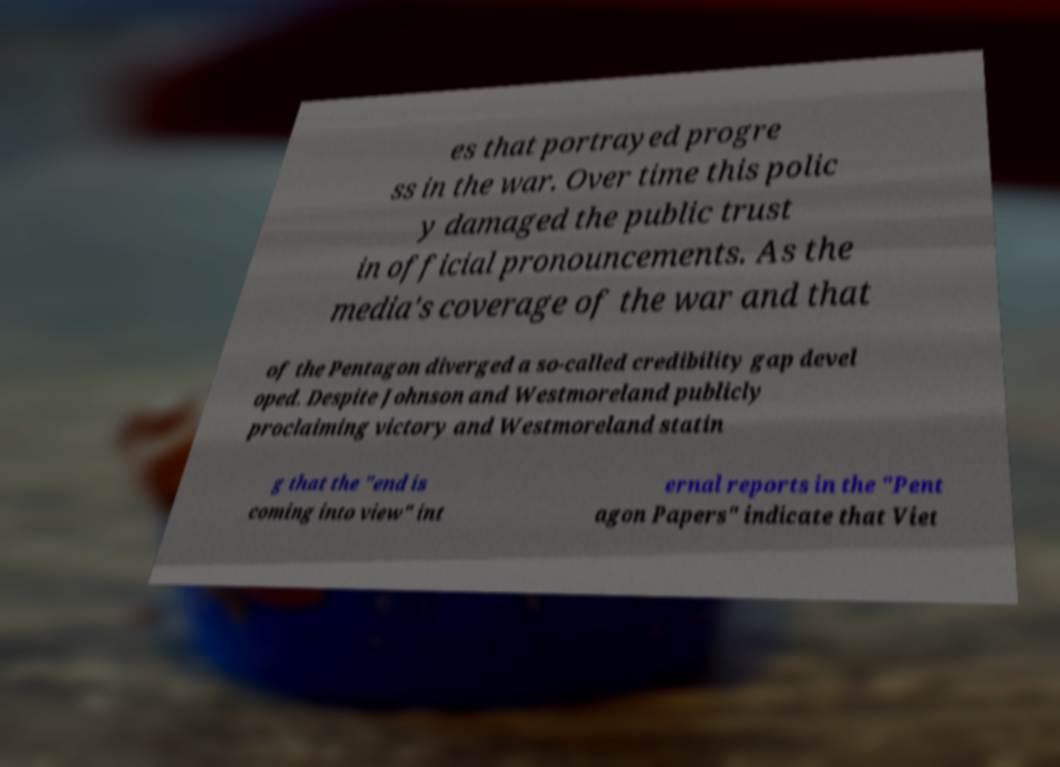Could you extract and type out the text from this image? es that portrayed progre ss in the war. Over time this polic y damaged the public trust in official pronouncements. As the media's coverage of the war and that of the Pentagon diverged a so-called credibility gap devel oped. Despite Johnson and Westmoreland publicly proclaiming victory and Westmoreland statin g that the "end is coming into view" int ernal reports in the "Pent agon Papers" indicate that Viet 